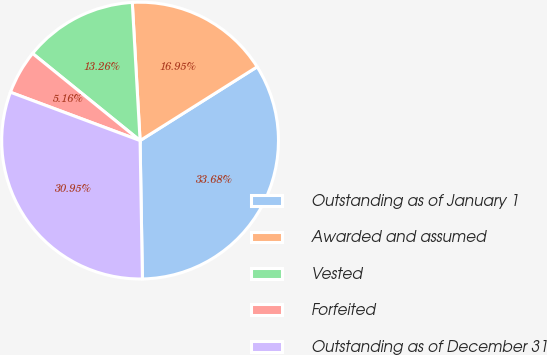<chart> <loc_0><loc_0><loc_500><loc_500><pie_chart><fcel>Outstanding as of January 1<fcel>Awarded and assumed<fcel>Vested<fcel>Forfeited<fcel>Outstanding as of December 31<nl><fcel>33.68%<fcel>16.95%<fcel>13.26%<fcel>5.16%<fcel>30.95%<nl></chart> 